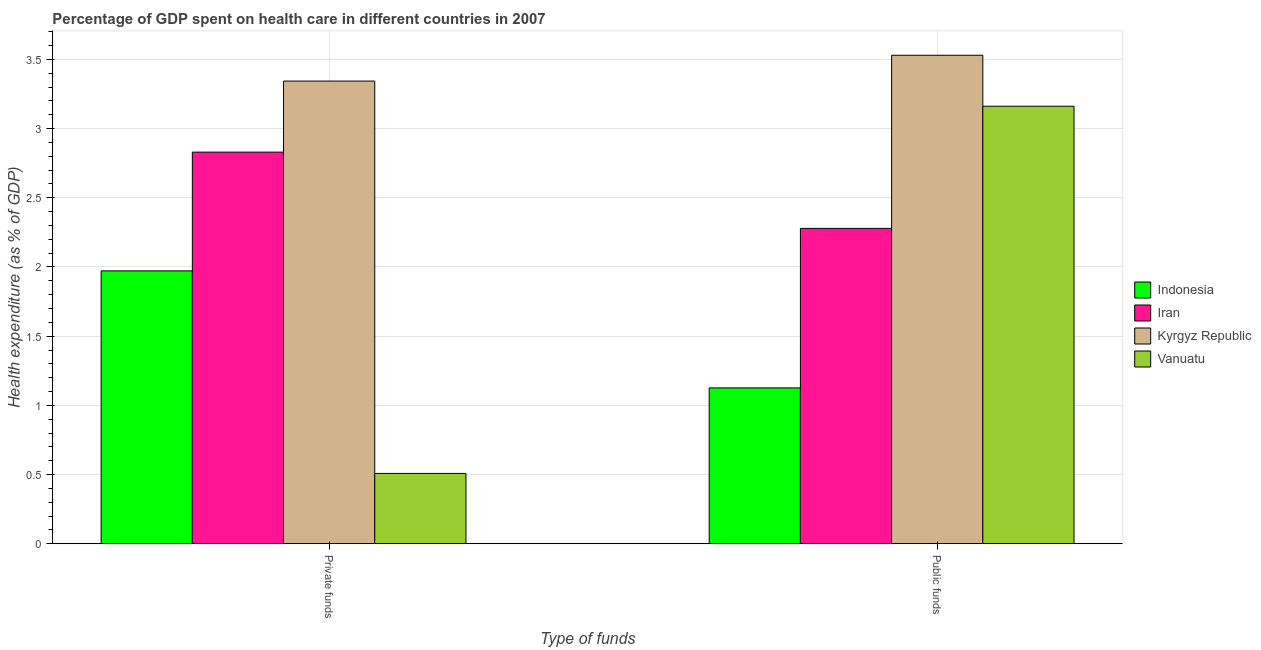How many different coloured bars are there?
Keep it short and to the point. 4. Are the number of bars per tick equal to the number of legend labels?
Offer a very short reply. Yes. Are the number of bars on each tick of the X-axis equal?
Offer a very short reply. Yes. How many bars are there on the 1st tick from the left?
Your answer should be compact. 4. What is the label of the 2nd group of bars from the left?
Keep it short and to the point. Public funds. What is the amount of public funds spent in healthcare in Vanuatu?
Make the answer very short. 3.16. Across all countries, what is the maximum amount of public funds spent in healthcare?
Your response must be concise. 3.53. Across all countries, what is the minimum amount of private funds spent in healthcare?
Your response must be concise. 0.51. In which country was the amount of public funds spent in healthcare maximum?
Offer a very short reply. Kyrgyz Republic. In which country was the amount of private funds spent in healthcare minimum?
Your answer should be very brief. Vanuatu. What is the total amount of public funds spent in healthcare in the graph?
Offer a very short reply. 10.1. What is the difference between the amount of private funds spent in healthcare in Kyrgyz Republic and that in Vanuatu?
Offer a terse response. 2.83. What is the difference between the amount of private funds spent in healthcare in Indonesia and the amount of public funds spent in healthcare in Kyrgyz Republic?
Keep it short and to the point. -1.56. What is the average amount of public funds spent in healthcare per country?
Give a very brief answer. 2.52. What is the difference between the amount of private funds spent in healthcare and amount of public funds spent in healthcare in Kyrgyz Republic?
Make the answer very short. -0.19. In how many countries, is the amount of public funds spent in healthcare greater than 1.8 %?
Your response must be concise. 3. What is the ratio of the amount of public funds spent in healthcare in Kyrgyz Republic to that in Iran?
Your answer should be compact. 1.55. Is the amount of public funds spent in healthcare in Vanuatu less than that in Iran?
Keep it short and to the point. No. What does the 3rd bar from the left in Private funds represents?
Ensure brevity in your answer.  Kyrgyz Republic. What does the 2nd bar from the right in Public funds represents?
Your response must be concise. Kyrgyz Republic. Are the values on the major ticks of Y-axis written in scientific E-notation?
Provide a short and direct response. No. Does the graph contain any zero values?
Your answer should be very brief. No. Where does the legend appear in the graph?
Keep it short and to the point. Center right. How are the legend labels stacked?
Your answer should be very brief. Vertical. What is the title of the graph?
Provide a short and direct response. Percentage of GDP spent on health care in different countries in 2007. What is the label or title of the X-axis?
Make the answer very short. Type of funds. What is the label or title of the Y-axis?
Make the answer very short. Health expenditure (as % of GDP). What is the Health expenditure (as % of GDP) of Indonesia in Private funds?
Keep it short and to the point. 1.97. What is the Health expenditure (as % of GDP) of Iran in Private funds?
Offer a very short reply. 2.83. What is the Health expenditure (as % of GDP) in Kyrgyz Republic in Private funds?
Your answer should be very brief. 3.34. What is the Health expenditure (as % of GDP) in Vanuatu in Private funds?
Provide a short and direct response. 0.51. What is the Health expenditure (as % of GDP) in Indonesia in Public funds?
Offer a terse response. 1.13. What is the Health expenditure (as % of GDP) in Iran in Public funds?
Your response must be concise. 2.28. What is the Health expenditure (as % of GDP) in Kyrgyz Republic in Public funds?
Your answer should be very brief. 3.53. What is the Health expenditure (as % of GDP) of Vanuatu in Public funds?
Make the answer very short. 3.16. Across all Type of funds, what is the maximum Health expenditure (as % of GDP) of Indonesia?
Provide a succinct answer. 1.97. Across all Type of funds, what is the maximum Health expenditure (as % of GDP) of Iran?
Provide a short and direct response. 2.83. Across all Type of funds, what is the maximum Health expenditure (as % of GDP) in Kyrgyz Republic?
Offer a very short reply. 3.53. Across all Type of funds, what is the maximum Health expenditure (as % of GDP) in Vanuatu?
Offer a very short reply. 3.16. Across all Type of funds, what is the minimum Health expenditure (as % of GDP) in Indonesia?
Give a very brief answer. 1.13. Across all Type of funds, what is the minimum Health expenditure (as % of GDP) in Iran?
Provide a short and direct response. 2.28. Across all Type of funds, what is the minimum Health expenditure (as % of GDP) in Kyrgyz Republic?
Ensure brevity in your answer.  3.34. Across all Type of funds, what is the minimum Health expenditure (as % of GDP) in Vanuatu?
Your answer should be compact. 0.51. What is the total Health expenditure (as % of GDP) of Indonesia in the graph?
Provide a succinct answer. 3.1. What is the total Health expenditure (as % of GDP) of Iran in the graph?
Provide a succinct answer. 5.11. What is the total Health expenditure (as % of GDP) in Kyrgyz Republic in the graph?
Offer a terse response. 6.87. What is the total Health expenditure (as % of GDP) in Vanuatu in the graph?
Provide a succinct answer. 3.67. What is the difference between the Health expenditure (as % of GDP) in Indonesia in Private funds and that in Public funds?
Your answer should be very brief. 0.85. What is the difference between the Health expenditure (as % of GDP) of Iran in Private funds and that in Public funds?
Give a very brief answer. 0.55. What is the difference between the Health expenditure (as % of GDP) in Kyrgyz Republic in Private funds and that in Public funds?
Offer a terse response. -0.19. What is the difference between the Health expenditure (as % of GDP) of Vanuatu in Private funds and that in Public funds?
Make the answer very short. -2.65. What is the difference between the Health expenditure (as % of GDP) of Indonesia in Private funds and the Health expenditure (as % of GDP) of Iran in Public funds?
Offer a very short reply. -0.31. What is the difference between the Health expenditure (as % of GDP) of Indonesia in Private funds and the Health expenditure (as % of GDP) of Kyrgyz Republic in Public funds?
Give a very brief answer. -1.56. What is the difference between the Health expenditure (as % of GDP) of Indonesia in Private funds and the Health expenditure (as % of GDP) of Vanuatu in Public funds?
Provide a succinct answer. -1.19. What is the difference between the Health expenditure (as % of GDP) of Iran in Private funds and the Health expenditure (as % of GDP) of Vanuatu in Public funds?
Offer a very short reply. -0.33. What is the difference between the Health expenditure (as % of GDP) of Kyrgyz Republic in Private funds and the Health expenditure (as % of GDP) of Vanuatu in Public funds?
Offer a terse response. 0.18. What is the average Health expenditure (as % of GDP) in Indonesia per Type of funds?
Provide a short and direct response. 1.55. What is the average Health expenditure (as % of GDP) in Iran per Type of funds?
Provide a succinct answer. 2.55. What is the average Health expenditure (as % of GDP) of Kyrgyz Republic per Type of funds?
Ensure brevity in your answer.  3.44. What is the average Health expenditure (as % of GDP) in Vanuatu per Type of funds?
Provide a succinct answer. 1.83. What is the difference between the Health expenditure (as % of GDP) of Indonesia and Health expenditure (as % of GDP) of Iran in Private funds?
Your answer should be compact. -0.86. What is the difference between the Health expenditure (as % of GDP) of Indonesia and Health expenditure (as % of GDP) of Kyrgyz Republic in Private funds?
Provide a short and direct response. -1.37. What is the difference between the Health expenditure (as % of GDP) of Indonesia and Health expenditure (as % of GDP) of Vanuatu in Private funds?
Provide a short and direct response. 1.46. What is the difference between the Health expenditure (as % of GDP) of Iran and Health expenditure (as % of GDP) of Kyrgyz Republic in Private funds?
Make the answer very short. -0.51. What is the difference between the Health expenditure (as % of GDP) in Iran and Health expenditure (as % of GDP) in Vanuatu in Private funds?
Provide a short and direct response. 2.32. What is the difference between the Health expenditure (as % of GDP) in Kyrgyz Republic and Health expenditure (as % of GDP) in Vanuatu in Private funds?
Your answer should be very brief. 2.83. What is the difference between the Health expenditure (as % of GDP) in Indonesia and Health expenditure (as % of GDP) in Iran in Public funds?
Keep it short and to the point. -1.15. What is the difference between the Health expenditure (as % of GDP) of Indonesia and Health expenditure (as % of GDP) of Kyrgyz Republic in Public funds?
Your answer should be compact. -2.4. What is the difference between the Health expenditure (as % of GDP) of Indonesia and Health expenditure (as % of GDP) of Vanuatu in Public funds?
Give a very brief answer. -2.04. What is the difference between the Health expenditure (as % of GDP) of Iran and Health expenditure (as % of GDP) of Kyrgyz Republic in Public funds?
Your response must be concise. -1.25. What is the difference between the Health expenditure (as % of GDP) of Iran and Health expenditure (as % of GDP) of Vanuatu in Public funds?
Provide a succinct answer. -0.88. What is the difference between the Health expenditure (as % of GDP) in Kyrgyz Republic and Health expenditure (as % of GDP) in Vanuatu in Public funds?
Keep it short and to the point. 0.37. What is the ratio of the Health expenditure (as % of GDP) of Indonesia in Private funds to that in Public funds?
Keep it short and to the point. 1.75. What is the ratio of the Health expenditure (as % of GDP) in Iran in Private funds to that in Public funds?
Give a very brief answer. 1.24. What is the ratio of the Health expenditure (as % of GDP) in Kyrgyz Republic in Private funds to that in Public funds?
Your response must be concise. 0.95. What is the ratio of the Health expenditure (as % of GDP) of Vanuatu in Private funds to that in Public funds?
Ensure brevity in your answer.  0.16. What is the difference between the highest and the second highest Health expenditure (as % of GDP) in Indonesia?
Your answer should be compact. 0.85. What is the difference between the highest and the second highest Health expenditure (as % of GDP) of Iran?
Provide a succinct answer. 0.55. What is the difference between the highest and the second highest Health expenditure (as % of GDP) of Kyrgyz Republic?
Keep it short and to the point. 0.19. What is the difference between the highest and the second highest Health expenditure (as % of GDP) in Vanuatu?
Your answer should be compact. 2.65. What is the difference between the highest and the lowest Health expenditure (as % of GDP) in Indonesia?
Ensure brevity in your answer.  0.85. What is the difference between the highest and the lowest Health expenditure (as % of GDP) in Iran?
Offer a very short reply. 0.55. What is the difference between the highest and the lowest Health expenditure (as % of GDP) in Kyrgyz Republic?
Offer a terse response. 0.19. What is the difference between the highest and the lowest Health expenditure (as % of GDP) of Vanuatu?
Keep it short and to the point. 2.65. 